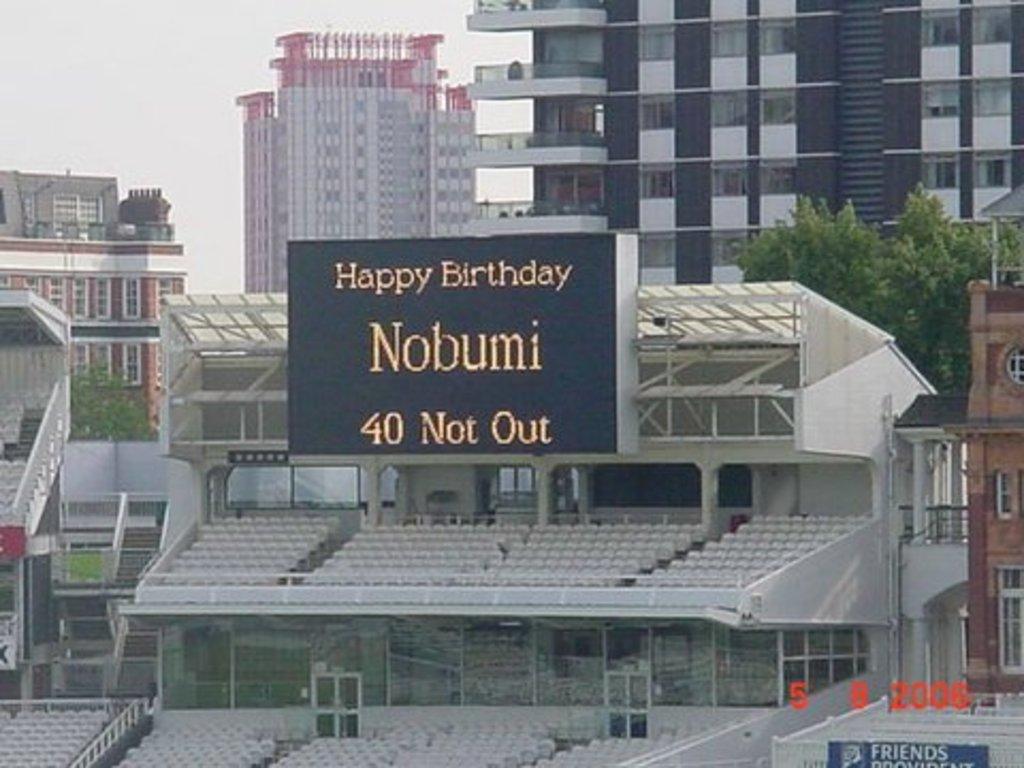How old is the birthday boy?
Provide a short and direct response. 40. What occasion is nobumi celebrating?
Provide a succinct answer. Birthday. 